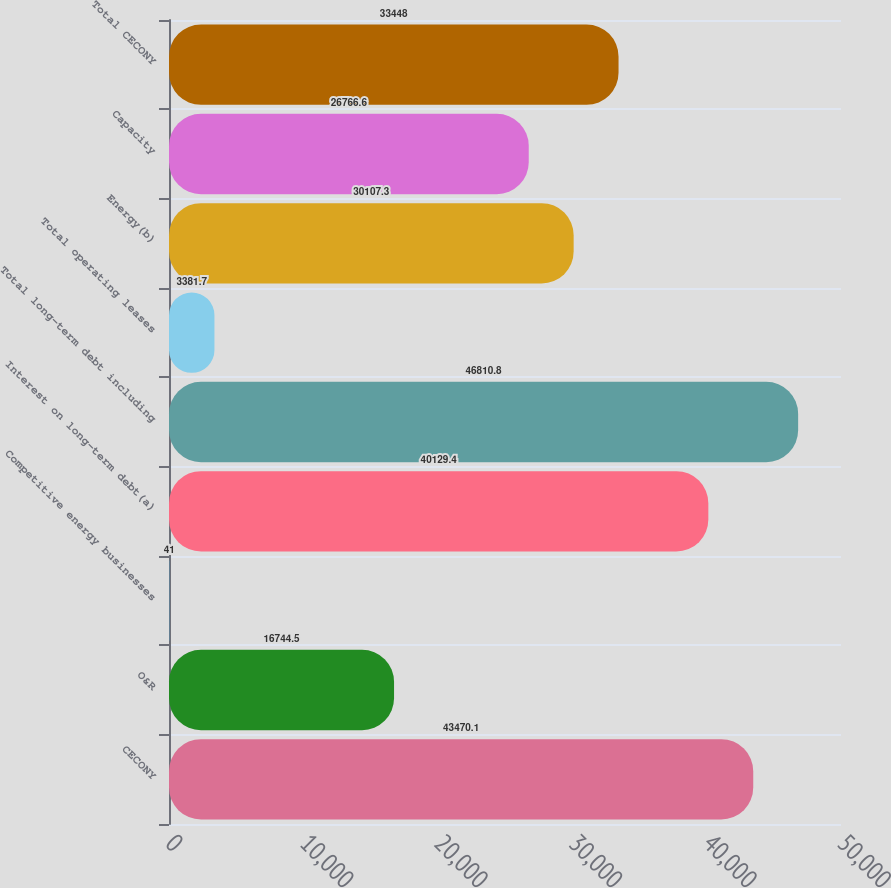Convert chart. <chart><loc_0><loc_0><loc_500><loc_500><bar_chart><fcel>CECONY<fcel>O&R<fcel>Competitive energy businesses<fcel>Interest on long-term debt(a)<fcel>Total long-term debt including<fcel>Total operating leases<fcel>Energy(b)<fcel>Capacity<fcel>Total CECONY<nl><fcel>43470.1<fcel>16744.5<fcel>41<fcel>40129.4<fcel>46810.8<fcel>3381.7<fcel>30107.3<fcel>26766.6<fcel>33448<nl></chart> 